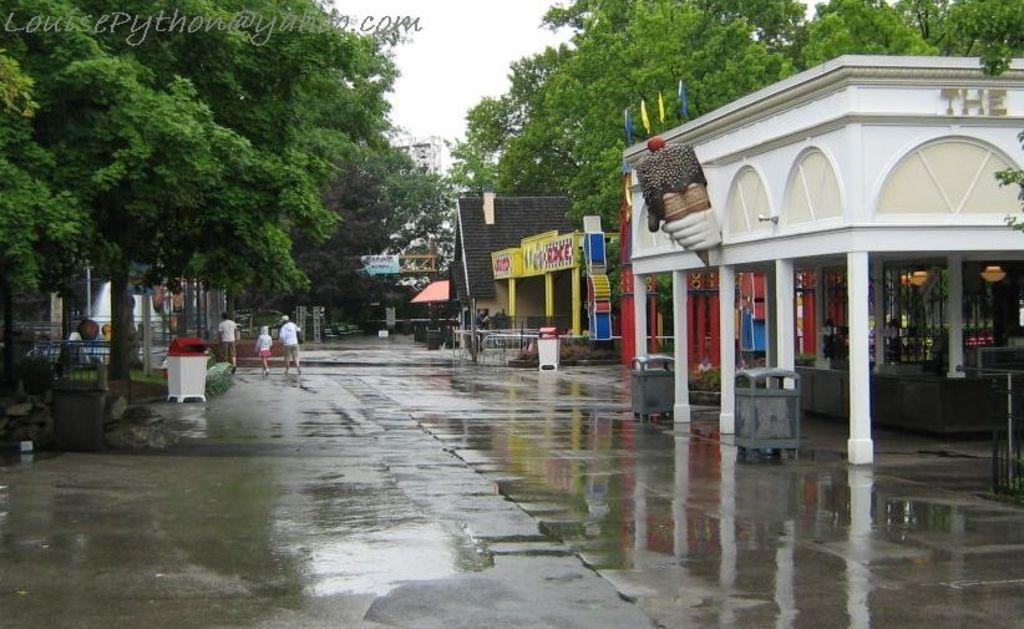In one or two sentences, can you explain what this image depicts? This picture consist of a main road and left side there is a and there are persons walking on the road and there is a red color box kept on the road on the left side. And there is a building visible on the left side and there are some trees visible on the right side and there is a sky visible on the middle and there are some trolleys kept on the right side. 